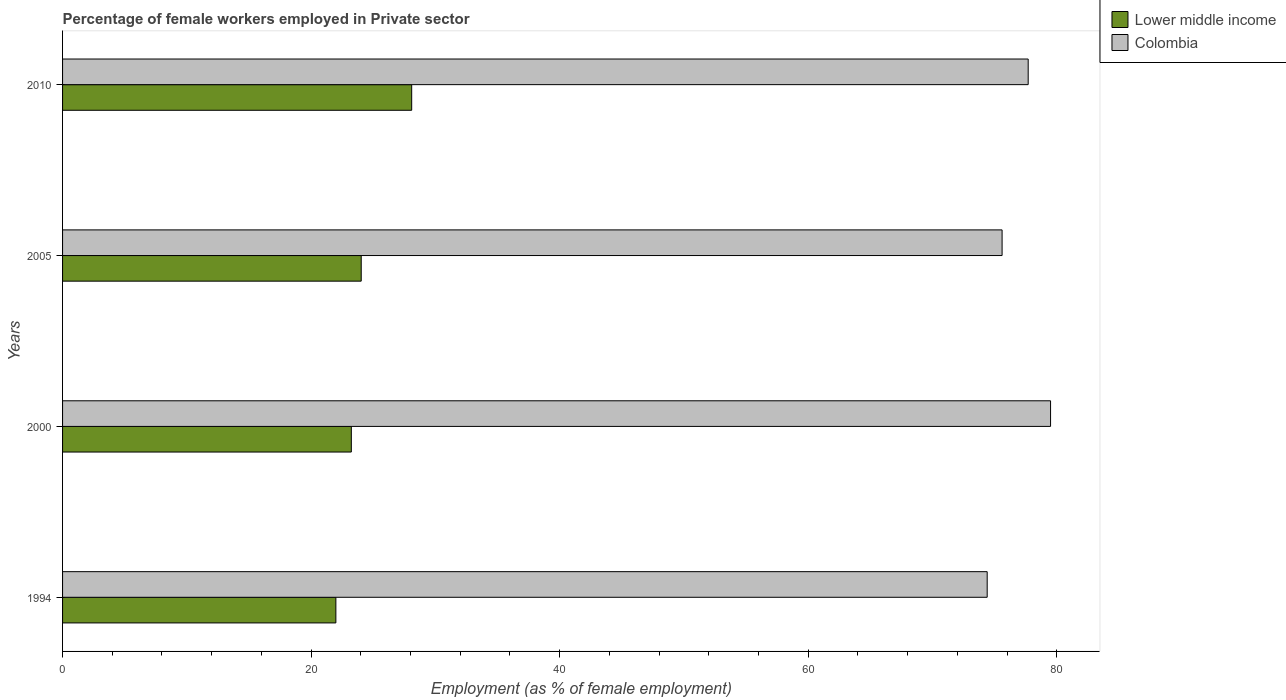Are the number of bars per tick equal to the number of legend labels?
Your answer should be very brief. Yes. How many bars are there on the 1st tick from the bottom?
Make the answer very short. 2. In how many cases, is the number of bars for a given year not equal to the number of legend labels?
Make the answer very short. 0. What is the percentage of females employed in Private sector in Lower middle income in 2010?
Provide a succinct answer. 28.09. Across all years, what is the maximum percentage of females employed in Private sector in Colombia?
Keep it short and to the point. 79.5. Across all years, what is the minimum percentage of females employed in Private sector in Colombia?
Offer a terse response. 74.4. What is the total percentage of females employed in Private sector in Colombia in the graph?
Ensure brevity in your answer.  307.2. What is the difference between the percentage of females employed in Private sector in Lower middle income in 2000 and that in 2005?
Your response must be concise. -0.8. What is the difference between the percentage of females employed in Private sector in Lower middle income in 2005 and the percentage of females employed in Private sector in Colombia in 2000?
Offer a terse response. -55.47. What is the average percentage of females employed in Private sector in Lower middle income per year?
Your answer should be very brief. 24.34. In the year 2005, what is the difference between the percentage of females employed in Private sector in Lower middle income and percentage of females employed in Private sector in Colombia?
Give a very brief answer. -51.57. What is the ratio of the percentage of females employed in Private sector in Colombia in 1994 to that in 2005?
Your answer should be very brief. 0.98. Is the percentage of females employed in Private sector in Colombia in 1994 less than that in 2005?
Your answer should be compact. Yes. What is the difference between the highest and the second highest percentage of females employed in Private sector in Lower middle income?
Make the answer very short. 4.06. What is the difference between the highest and the lowest percentage of females employed in Private sector in Colombia?
Give a very brief answer. 5.1. In how many years, is the percentage of females employed in Private sector in Lower middle income greater than the average percentage of females employed in Private sector in Lower middle income taken over all years?
Your answer should be very brief. 1. What does the 2nd bar from the top in 2000 represents?
Offer a terse response. Lower middle income. What does the 1st bar from the bottom in 1994 represents?
Ensure brevity in your answer.  Lower middle income. What is the difference between two consecutive major ticks on the X-axis?
Keep it short and to the point. 20. Does the graph contain any zero values?
Your answer should be compact. No. How many legend labels are there?
Provide a short and direct response. 2. What is the title of the graph?
Your answer should be very brief. Percentage of female workers employed in Private sector. What is the label or title of the X-axis?
Your answer should be compact. Employment (as % of female employment). What is the label or title of the Y-axis?
Provide a succinct answer. Years. What is the Employment (as % of female employment) of Lower middle income in 1994?
Ensure brevity in your answer.  21.99. What is the Employment (as % of female employment) in Colombia in 1994?
Offer a very short reply. 74.4. What is the Employment (as % of female employment) of Lower middle income in 2000?
Your answer should be very brief. 23.24. What is the Employment (as % of female employment) of Colombia in 2000?
Provide a succinct answer. 79.5. What is the Employment (as % of female employment) of Lower middle income in 2005?
Your response must be concise. 24.03. What is the Employment (as % of female employment) in Colombia in 2005?
Make the answer very short. 75.6. What is the Employment (as % of female employment) in Lower middle income in 2010?
Keep it short and to the point. 28.09. What is the Employment (as % of female employment) of Colombia in 2010?
Offer a very short reply. 77.7. Across all years, what is the maximum Employment (as % of female employment) of Lower middle income?
Offer a terse response. 28.09. Across all years, what is the maximum Employment (as % of female employment) of Colombia?
Make the answer very short. 79.5. Across all years, what is the minimum Employment (as % of female employment) of Lower middle income?
Make the answer very short. 21.99. Across all years, what is the minimum Employment (as % of female employment) in Colombia?
Provide a short and direct response. 74.4. What is the total Employment (as % of female employment) of Lower middle income in the graph?
Make the answer very short. 97.35. What is the total Employment (as % of female employment) in Colombia in the graph?
Your response must be concise. 307.2. What is the difference between the Employment (as % of female employment) in Lower middle income in 1994 and that in 2000?
Your answer should be compact. -1.24. What is the difference between the Employment (as % of female employment) in Colombia in 1994 and that in 2000?
Give a very brief answer. -5.1. What is the difference between the Employment (as % of female employment) in Lower middle income in 1994 and that in 2005?
Provide a succinct answer. -2.04. What is the difference between the Employment (as % of female employment) in Lower middle income in 1994 and that in 2010?
Keep it short and to the point. -6.1. What is the difference between the Employment (as % of female employment) of Colombia in 1994 and that in 2010?
Give a very brief answer. -3.3. What is the difference between the Employment (as % of female employment) in Lower middle income in 2000 and that in 2005?
Offer a very short reply. -0.8. What is the difference between the Employment (as % of female employment) in Colombia in 2000 and that in 2005?
Your response must be concise. 3.9. What is the difference between the Employment (as % of female employment) in Lower middle income in 2000 and that in 2010?
Keep it short and to the point. -4.86. What is the difference between the Employment (as % of female employment) in Colombia in 2000 and that in 2010?
Ensure brevity in your answer.  1.8. What is the difference between the Employment (as % of female employment) in Lower middle income in 2005 and that in 2010?
Your answer should be compact. -4.06. What is the difference between the Employment (as % of female employment) of Colombia in 2005 and that in 2010?
Keep it short and to the point. -2.1. What is the difference between the Employment (as % of female employment) in Lower middle income in 1994 and the Employment (as % of female employment) in Colombia in 2000?
Give a very brief answer. -57.51. What is the difference between the Employment (as % of female employment) in Lower middle income in 1994 and the Employment (as % of female employment) in Colombia in 2005?
Offer a terse response. -53.61. What is the difference between the Employment (as % of female employment) of Lower middle income in 1994 and the Employment (as % of female employment) of Colombia in 2010?
Make the answer very short. -55.71. What is the difference between the Employment (as % of female employment) of Lower middle income in 2000 and the Employment (as % of female employment) of Colombia in 2005?
Ensure brevity in your answer.  -52.36. What is the difference between the Employment (as % of female employment) of Lower middle income in 2000 and the Employment (as % of female employment) of Colombia in 2010?
Keep it short and to the point. -54.46. What is the difference between the Employment (as % of female employment) of Lower middle income in 2005 and the Employment (as % of female employment) of Colombia in 2010?
Your answer should be compact. -53.67. What is the average Employment (as % of female employment) of Lower middle income per year?
Your answer should be very brief. 24.34. What is the average Employment (as % of female employment) of Colombia per year?
Give a very brief answer. 76.8. In the year 1994, what is the difference between the Employment (as % of female employment) in Lower middle income and Employment (as % of female employment) in Colombia?
Your response must be concise. -52.41. In the year 2000, what is the difference between the Employment (as % of female employment) in Lower middle income and Employment (as % of female employment) in Colombia?
Offer a terse response. -56.26. In the year 2005, what is the difference between the Employment (as % of female employment) of Lower middle income and Employment (as % of female employment) of Colombia?
Offer a very short reply. -51.57. In the year 2010, what is the difference between the Employment (as % of female employment) of Lower middle income and Employment (as % of female employment) of Colombia?
Provide a short and direct response. -49.61. What is the ratio of the Employment (as % of female employment) in Lower middle income in 1994 to that in 2000?
Your response must be concise. 0.95. What is the ratio of the Employment (as % of female employment) in Colombia in 1994 to that in 2000?
Give a very brief answer. 0.94. What is the ratio of the Employment (as % of female employment) in Lower middle income in 1994 to that in 2005?
Give a very brief answer. 0.92. What is the ratio of the Employment (as % of female employment) of Colombia in 1994 to that in 2005?
Keep it short and to the point. 0.98. What is the ratio of the Employment (as % of female employment) in Lower middle income in 1994 to that in 2010?
Provide a succinct answer. 0.78. What is the ratio of the Employment (as % of female employment) in Colombia in 1994 to that in 2010?
Offer a very short reply. 0.96. What is the ratio of the Employment (as % of female employment) in Lower middle income in 2000 to that in 2005?
Offer a very short reply. 0.97. What is the ratio of the Employment (as % of female employment) of Colombia in 2000 to that in 2005?
Your answer should be compact. 1.05. What is the ratio of the Employment (as % of female employment) of Lower middle income in 2000 to that in 2010?
Make the answer very short. 0.83. What is the ratio of the Employment (as % of female employment) in Colombia in 2000 to that in 2010?
Your answer should be very brief. 1.02. What is the ratio of the Employment (as % of female employment) of Lower middle income in 2005 to that in 2010?
Your answer should be compact. 0.86. What is the ratio of the Employment (as % of female employment) in Colombia in 2005 to that in 2010?
Make the answer very short. 0.97. What is the difference between the highest and the second highest Employment (as % of female employment) in Lower middle income?
Give a very brief answer. 4.06. What is the difference between the highest and the second highest Employment (as % of female employment) in Colombia?
Your response must be concise. 1.8. What is the difference between the highest and the lowest Employment (as % of female employment) of Lower middle income?
Offer a terse response. 6.1. 